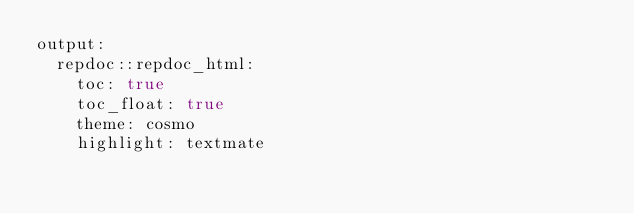Convert code to text. <code><loc_0><loc_0><loc_500><loc_500><_YAML_>output:
  repdoc::repdoc_html:
    toc: true
    toc_float: true
    theme: cosmo
    highlight: textmate
</code> 